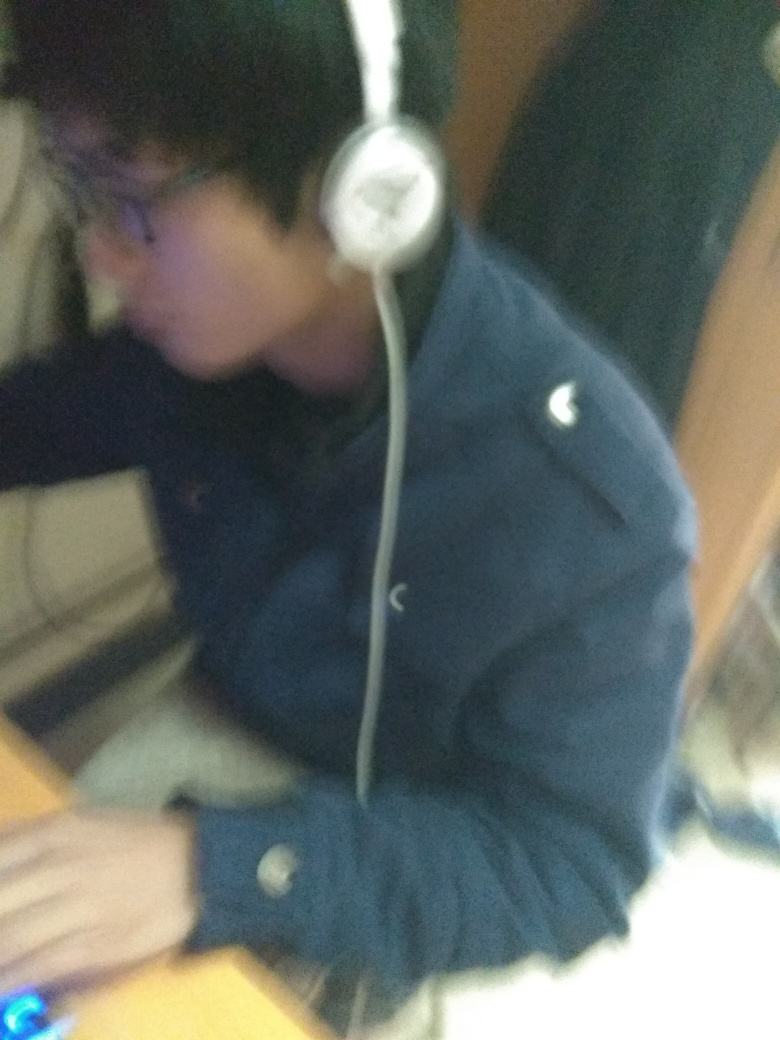Can you describe the style or quality of the clothing the person is wearing? The person is dressed in a dark, possibly navy blue jacket with a simple design and what appears to be a logo on the left chest. The style seems casual and comfortable, suitable for everyday wear. 